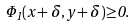Convert formula to latex. <formula><loc_0><loc_0><loc_500><loc_500>\Phi _ { 1 } ( x + \delta , y + \delta ) { \geq } 0 .</formula> 